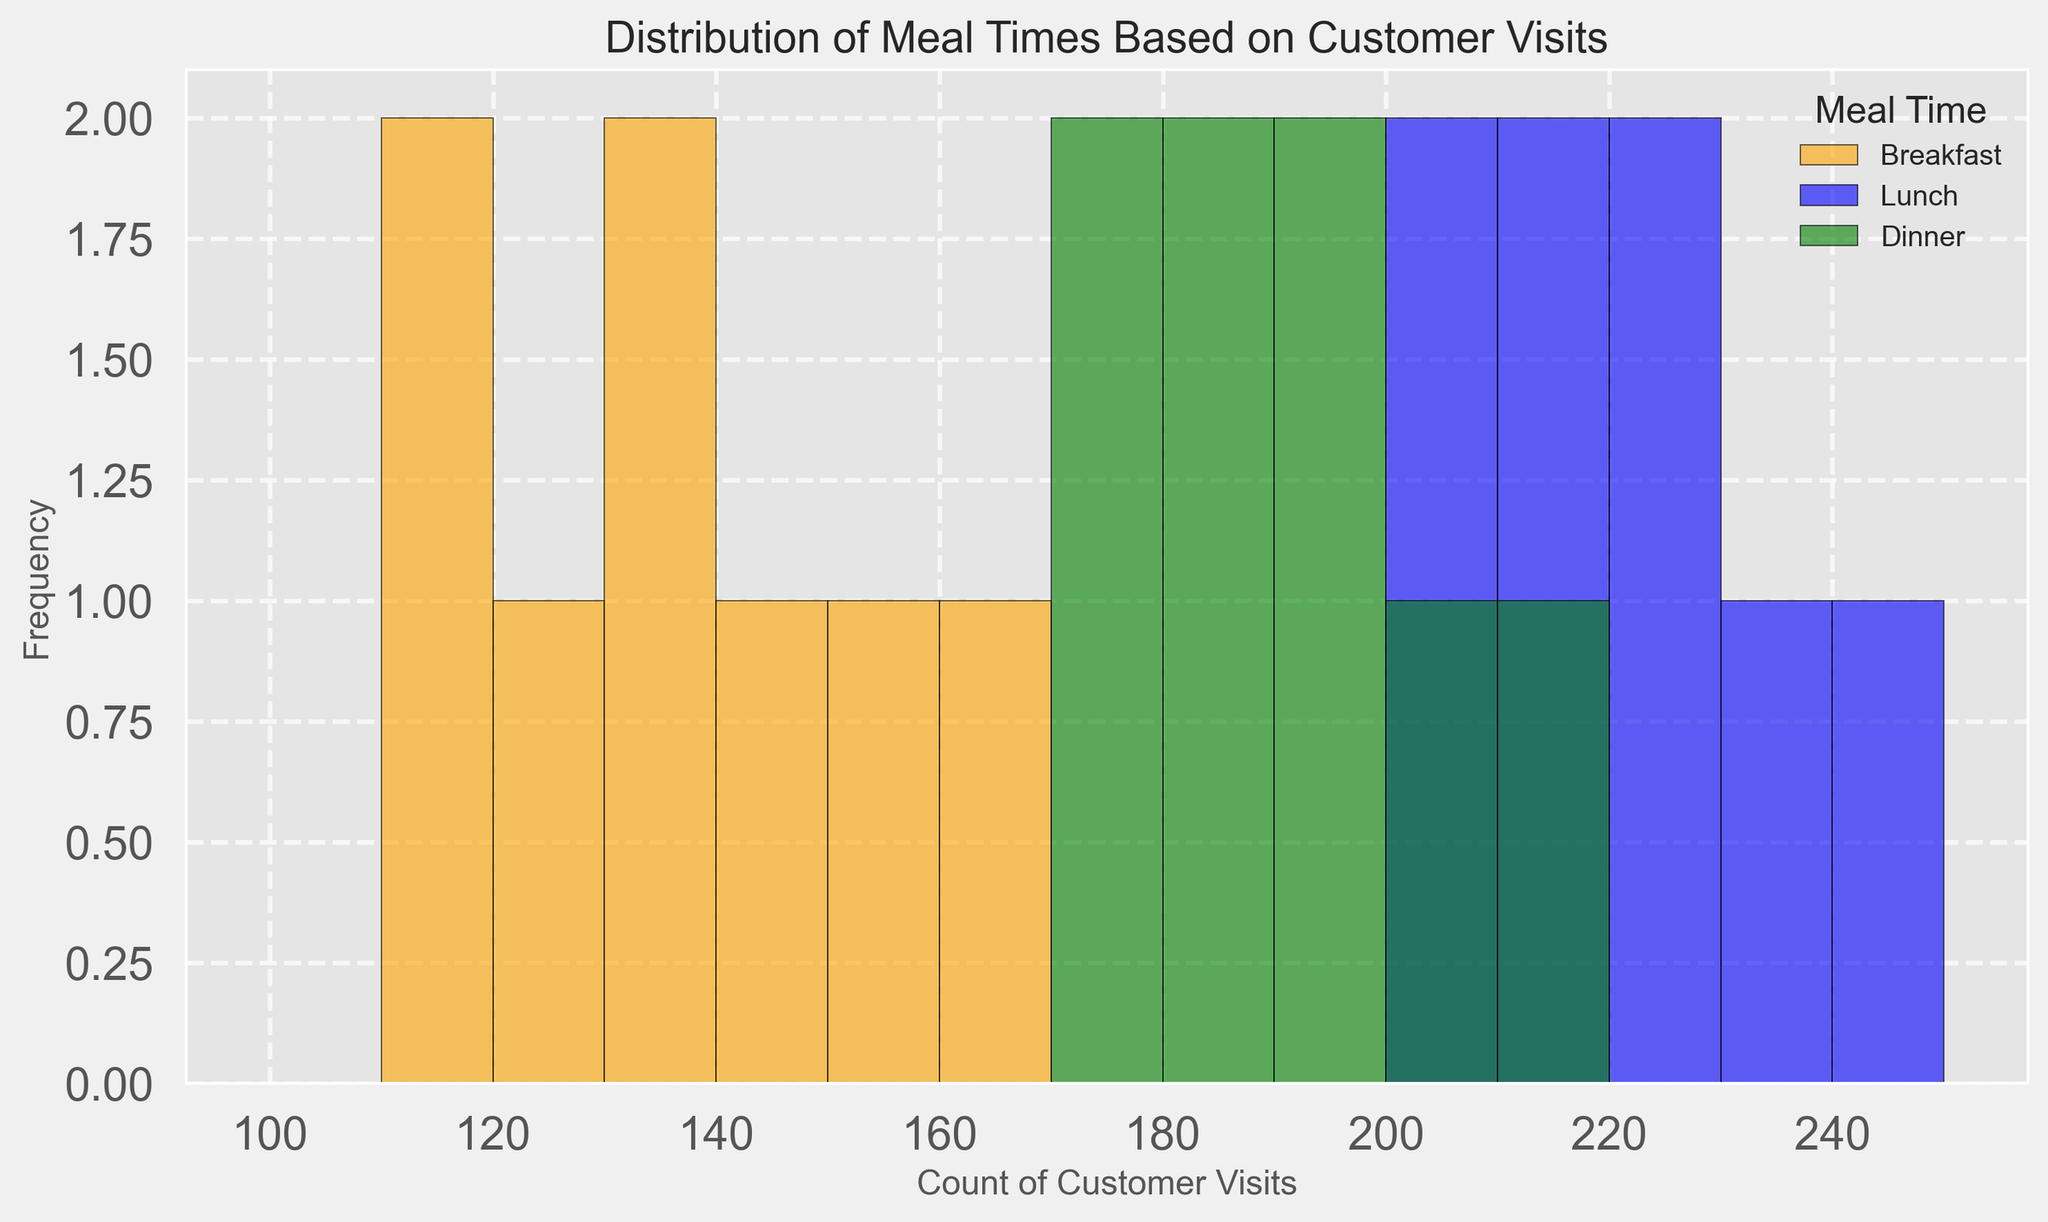What are the average counts of customer visits for each meal time? To find the average counts, sum the counts for each meal time and then divide by the number of data points for that meal time. For breakfast: (120+130+115+145+138+152+160+110)/8 = 134. For lunch: (200+220+210+230+215+205+225+240)/8 = 218.75. For dinner: (180+170+190+200+185+175+210+195)/8 = 188.75
Answer: 134, 218.75, 188.75 Which meal time has the highest frequency of customer visits between 200 and 210? Look at the histogram bins between 200 and 210 and compare the heights (frequencies) for each meal time. Lunch has heights of 1 at 200-210 and 3 at 210-220; dinner has heights of 2 at 200-210 and 1 at 210-220. Breakfast does not fall into this range. Therefore, lunch has the highest frequency
Answer: Lunch Does breakfast or dinner have a greater variation in customer visit counts? To compare variations, calculate the range for each. Breakfast range: max(160) - min(110) = 50. Dinner range: max(210) - min(170) = 40. Thus, breakfast has a greater variation
Answer: Breakfast What is the total number of customer visits recorded for all meal times combined? Sum all the customer visit counts across breakfast, lunch, and dinner. (120+130+115+145+138+152+160+110) + (200+220+210+230+215+205+225+240) + (180+170+190+200+185+175+210+195) = 1070
Answer: 1070 How does the frequency of customer visits for dinner compare to lunch between 190 and 200? Look at the histogram bins for 190-200. Dinner has frequencies of 1 at 190-200 and 1 at 200-210 summing up to 2, while lunch has 1 at 190-200 and 3 at 200-210 summing up to 4. Lunch has a higher frequency
Answer: Lunch Which meal time has the lowest frequency of customer visits above 220? Look at the histogram bins above 220 for each meal time. Breakfast does not appear above 220, lunch appears for 220-230 (2) and 230-240 (1), dinner does not appear above 200. Thus, breakfast and dinner tie at zero above 220
Answer: Breakfast, Dinner What is the most common range of customer visit counts for lunch? Identify the bins with the highest frequency for lunch. The bin 200-210 has a high frequency, but the bin 210-220 has the highest frequency for lunch. Therefore, 210-220 is the most common range
Answer: 210-220 What is the difference in the mean customer visit counts between breakfast and dinner? Calculate the means: Breakfast is 134, Dinner is 188.75. Difference: 188.75 - 134 = 54.75. Hence, the difference is 54.75
Answer: 54.75 Which meal time has a higher frequency of customer visits in the 170-180 range? Check the histogram bins for 170-180 for each meal time. Breakfast is not in this range, lunch not in this range, dinner has one count for 170-180. So, dinner has the higher frequency
Answer: Dinner 